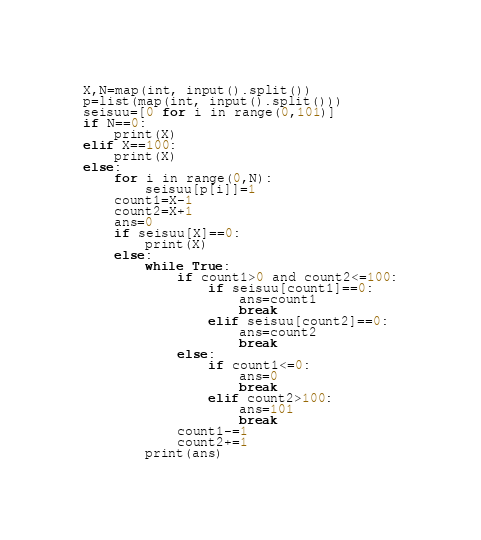Convert code to text. <code><loc_0><loc_0><loc_500><loc_500><_Python_>X,N=map(int, input().split())
p=list(map(int, input().split()))
seisuu=[0 for i in range(0,101)]
if N==0:
    print(X)
elif X==100:
    print(X)
else:
    for i in range(0,N):
        seisuu[p[i]]=1
    count1=X-1
    count2=X+1
    ans=0
    if seisuu[X]==0:
        print(X)
    else:
        while True:
            if count1>0 and count2<=100:
                if seisuu[count1]==0:
                    ans=count1
                    break
                elif seisuu[count2]==0:
                    ans=count2
                    break
            else:
                if count1<=0:
                    ans=0
                    break
                elif count2>100:
                    ans=101
                    break
            count1-=1
            count2+=1
        print(ans)</code> 